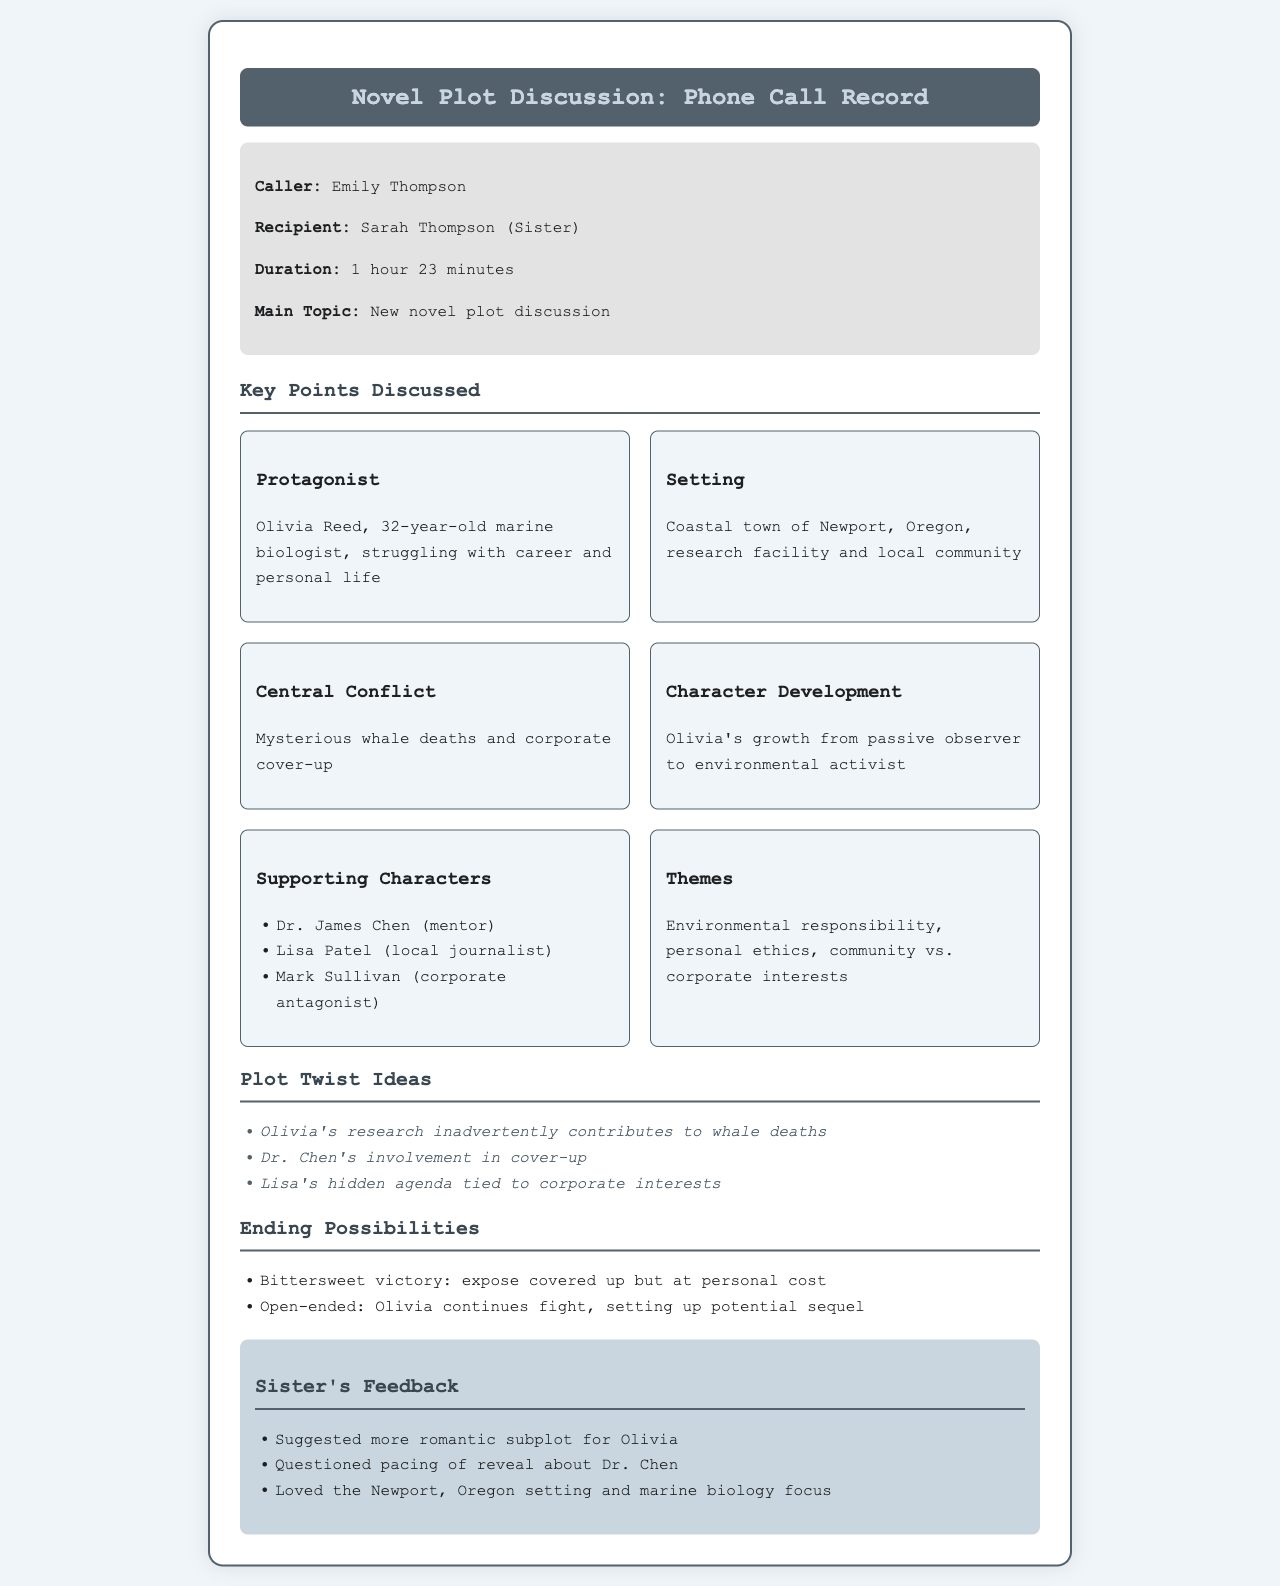What is the name of the protagonist? The protagonist's name is mentioned in the document as Olivia Reed.
Answer: Olivia Reed What is the setting of the novel? The document describes the location of the story, specifying it as a coastal town.
Answer: Coastal town of Newport, Oregon What is the central conflict? The document outlines the main issue that Olivia faces in the story regarding mysterious events.
Answer: Mysterious whale deaths and corporate cover-up How does Olivia's character develop? The document provides information about Olivia's growth throughout the story, indicating her change in role.
Answer: Growth from passive observer to environmental activist Who is the mentor character? The document lists supporting characters, highlighting the individual's role as a mentor to the protagonist.
Answer: Dr. James Chen What are two themes discussed in the document? The document outlines overarching ideas present in the narrative that reflect its deeper meanings or morals.
Answer: Environmental responsibility, personal ethics What is one of the plot twist ideas? The document provides several suggestions for surprising turns in the storyline, indicating a specific unexpected event.
Answer: Olivia's research inadvertently contributes to whale deaths What is Sarah’s feedback regarding the plot? The document includes a section where Sarah provides her opinions and suggestions about the novel.
Answer: Suggested more romantic subplot for Olivia How long was the phone call? The document states the duration of the conversation, which can be directly retrieved from the relevant detail.
Answer: 1 hour 23 minutes What is one ending possibility mentioned? The document lists potential conclusions to the story, summarizing one specific option as described.
Answer: Bittersweet victory: expose covered up but at personal cost 